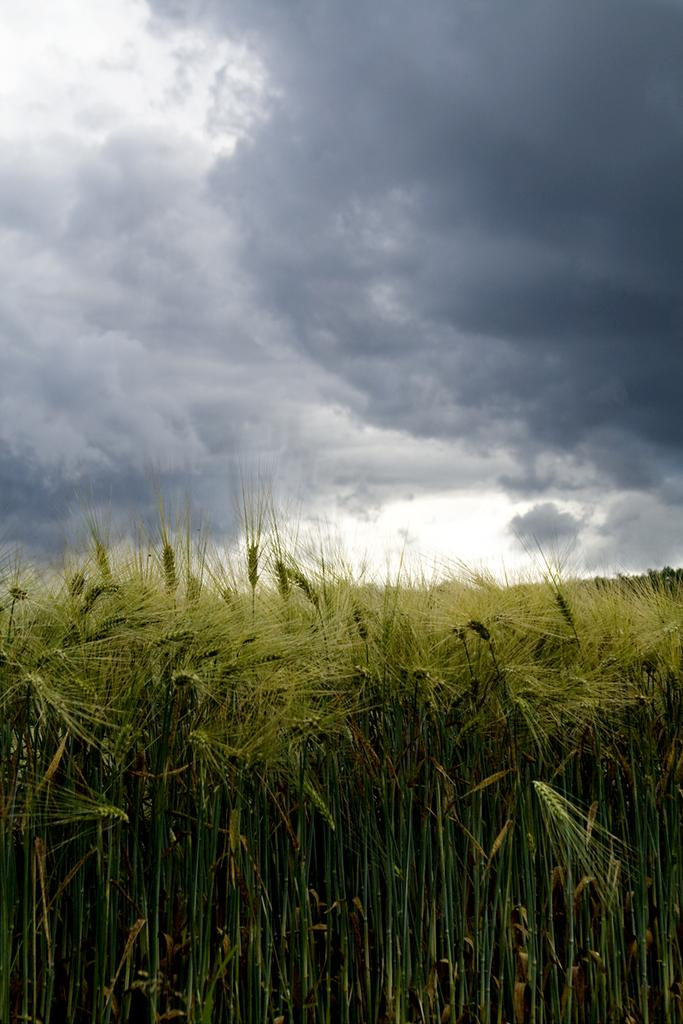What type of vegetation can be seen at the bottom of the image? There is a wheat field at the bottom of the image. What is visible in the sky at the top of the image? Clouds are present in the sky at the top of the image. What type of ship can be seen sailing through the wheat field in the image? There is no ship present in the image; it features a wheat field and clouds in the sky. How does the wind affect the wheat field in the image? The image does not show the provide information about the wind, so it cannot be determined how it affects the wheat field. 